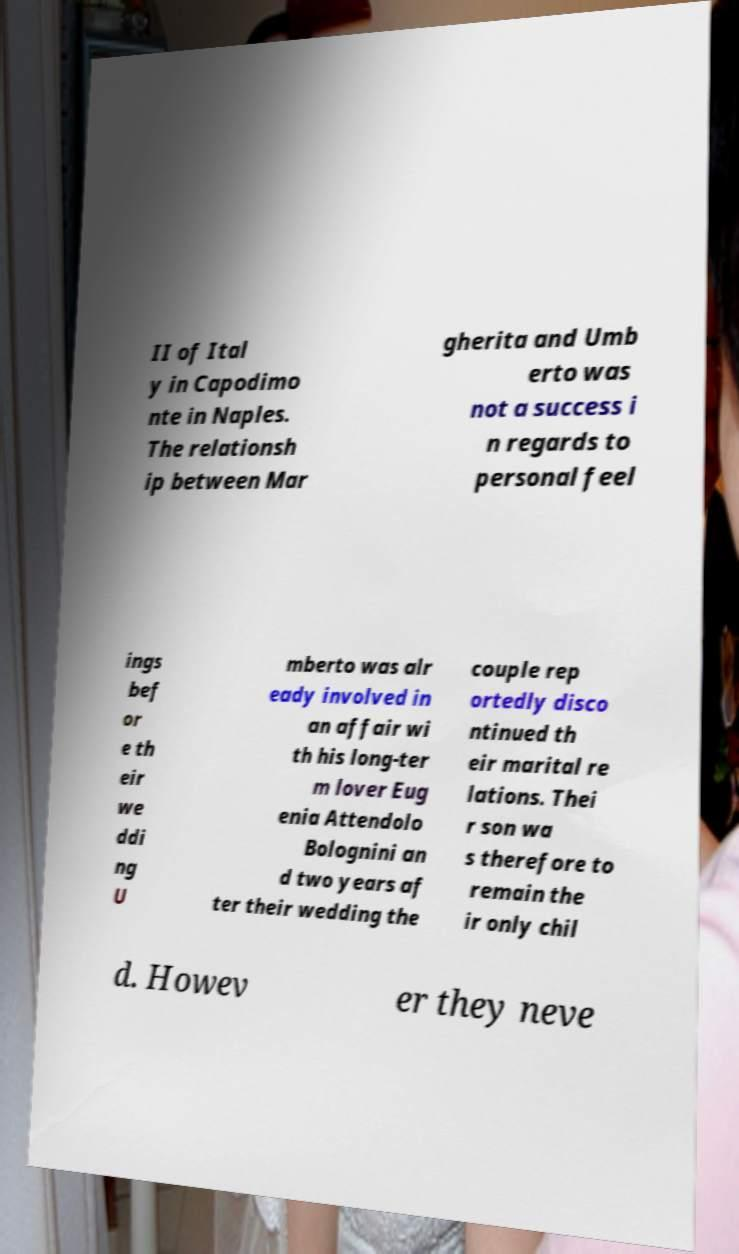For documentation purposes, I need the text within this image transcribed. Could you provide that? II of Ital y in Capodimo nte in Naples. The relationsh ip between Mar gherita and Umb erto was not a success i n regards to personal feel ings bef or e th eir we ddi ng U mberto was alr eady involved in an affair wi th his long-ter m lover Eug enia Attendolo Bolognini an d two years af ter their wedding the couple rep ortedly disco ntinued th eir marital re lations. Thei r son wa s therefore to remain the ir only chil d. Howev er they neve 